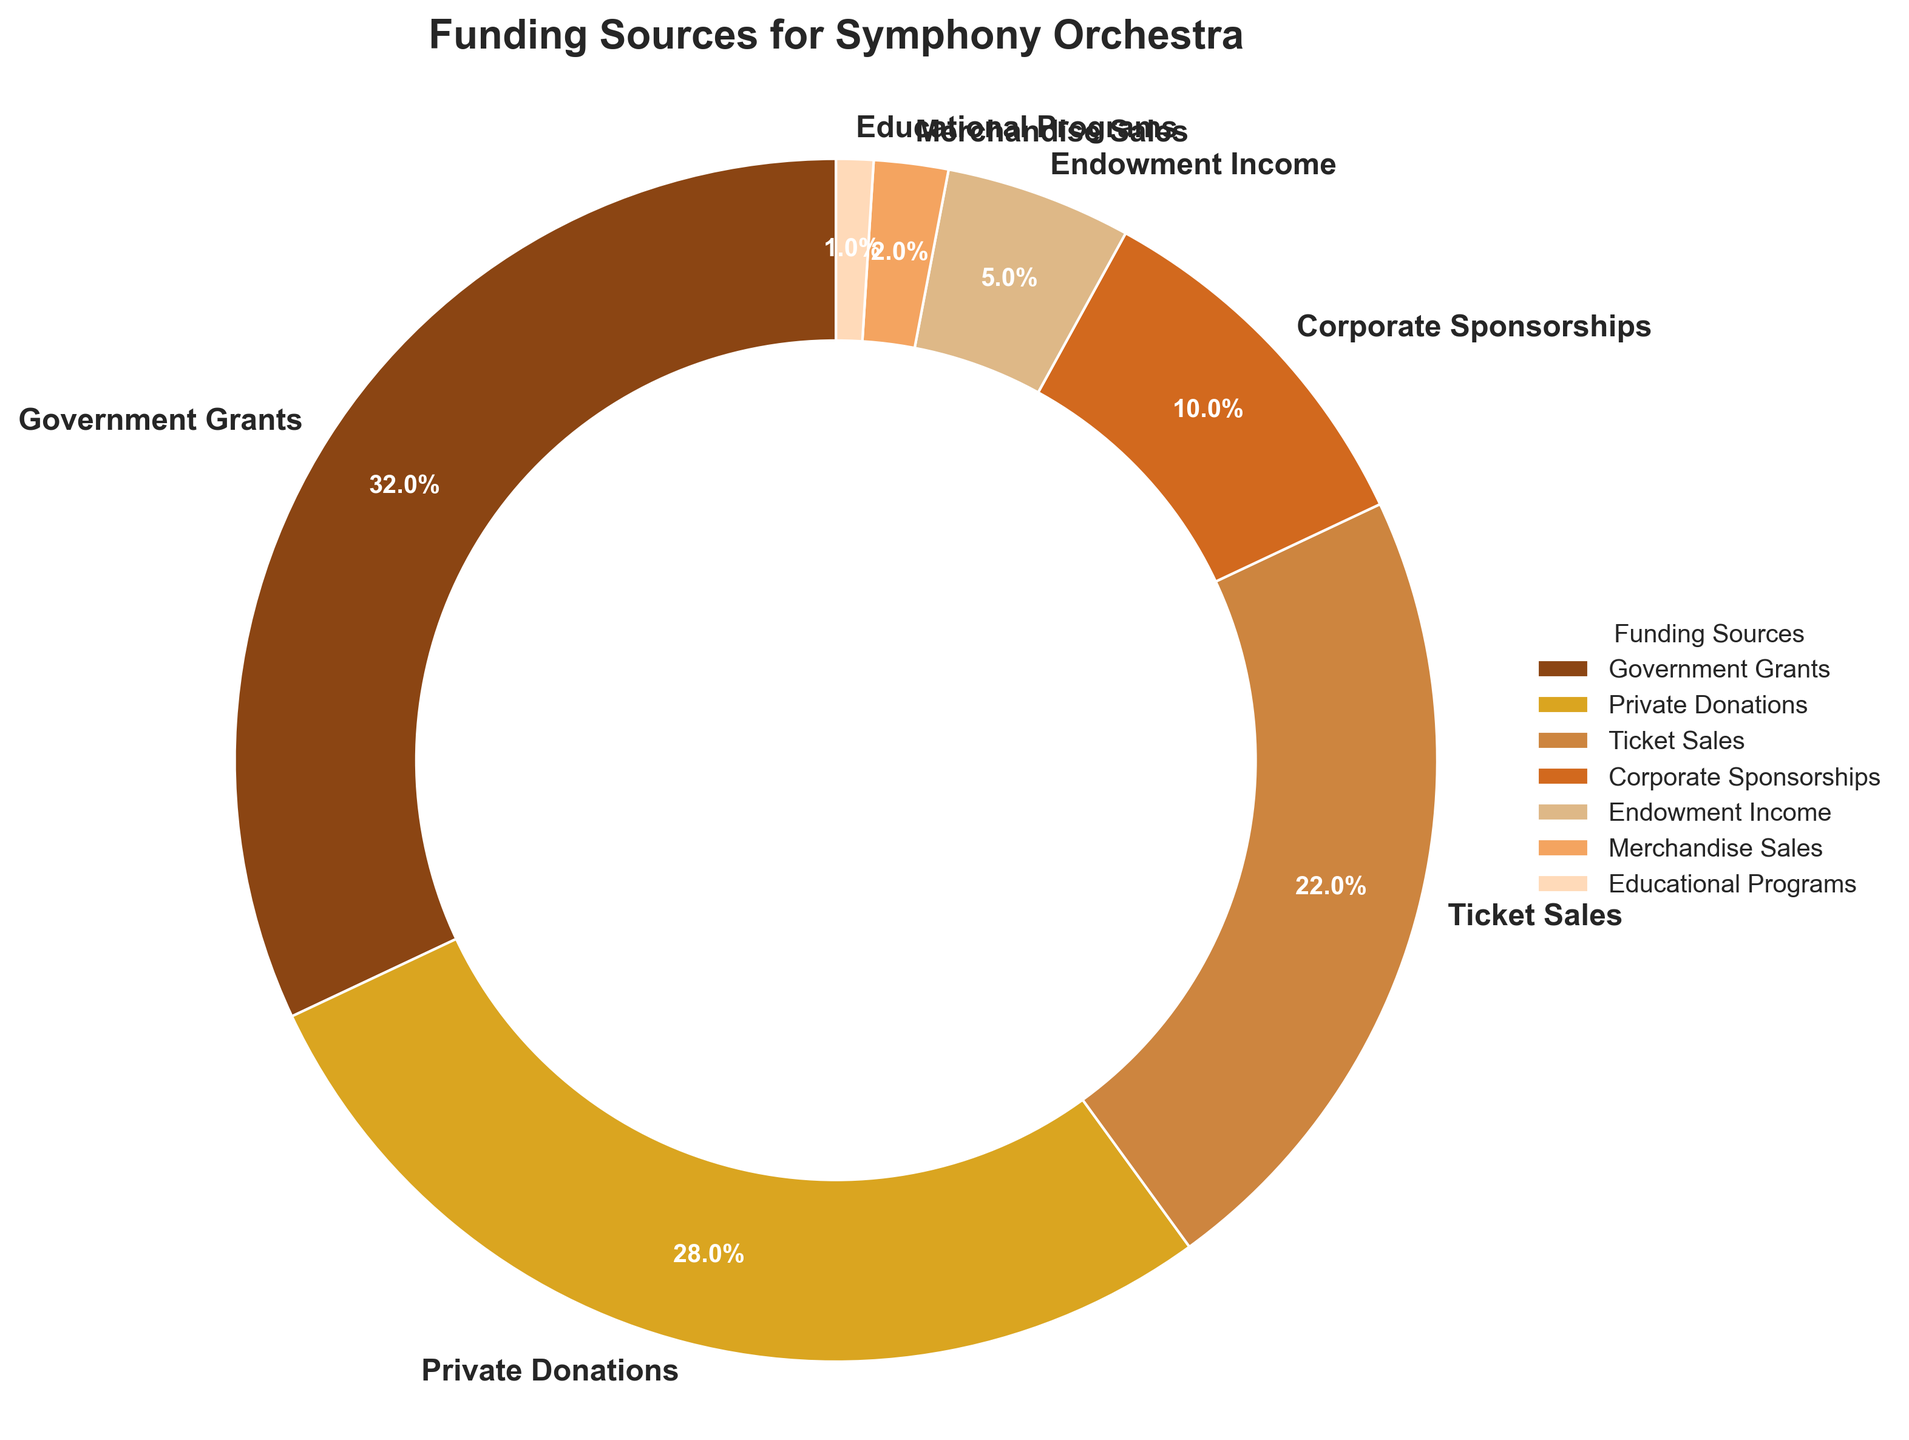What's the largest source of funding for the orchestra? Examine the size of each slice in the pie chart and identify the label with the largest percentage. The largest slice is labeled "Government Grants" with 32%.
Answer: Government Grants Which funding source contributes more: Ticket Sales or Private Donations? Compare the sizes of the slices labeled "Ticket Sales" and "Private Donations". Ticket Sales contribute 22% and Private Donations contribute 28%.
Answer: Private Donations What is the combined percentage of Endowment Income, Merchandise Sales, and Educational Programs? Sum the percentages associated with the slices labeled "Endowment Income" (5%), "Merchandise Sales" (2%), and "Educational Programs" (1%). 5% + 2% + 1% = 8%
Answer: 8% Is the percentage from Corporate Sponsorships greater than that from Endowment Income? Compare the sizes of the slices labeled "Corporate Sponsorships" (10%) and "Endowment Income" (5%). 10% is greater than 5%.
Answer: Yes What is the difference in percentage between Government Grants and Ticket Sales? Subtract the percentage for Ticket Sales (22%) from the percentage for Government Grants (32%). 32% - 22% = 10%
Answer: 10% How does the percentage from Private Donations compare to the combined percentage of Merchandise Sales and Educational Programs? First, sum the percentages for Merchandise Sales (2%) and Educational Programs (1%). The combined percentage is 3%. Private Donations is 28%. 28% is greater than 3%.
Answer: Greater Which funding sources together make up more than half of the total funding? Examine the pie chart and determine the combined percentages. Government Grants (32%), Private Donations (28%), and Ticket Sales (22%) need to be combined. 32% + 28% + 22% = 82%. These three sources together make up more than half.
Answer: Government Grants, Private Donations, and Ticket Sales What percentage of total funding comes from sources other than Government Grants, Private Donations, and Ticket Sales? Subtract the sum of the percentages of Government Grants (32%), Private Donations (28%), and Ticket Sales (22%) from 100%. 100% - (32% + 28% + 22%) = 18%
Answer: 18% What is the percentage difference between the least and the largest source of funding? Identify the largest and the least percentages in the pie chart. The largest is "Government Grants" at 32%, and the least is "Educational Programs" at 1%. Subtract 1% from 32%. 32% - 1% = 31%
Answer: 31% 